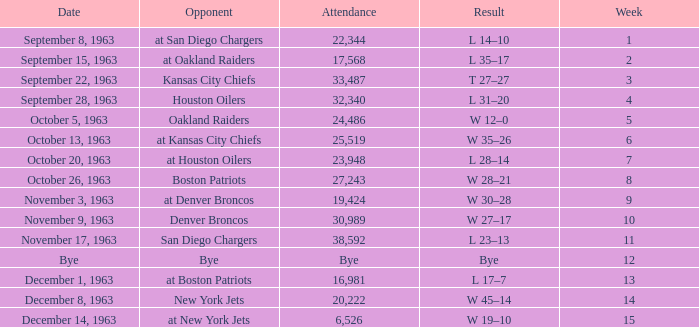Which Opponent has a Result of w 19–10? At new york jets. 